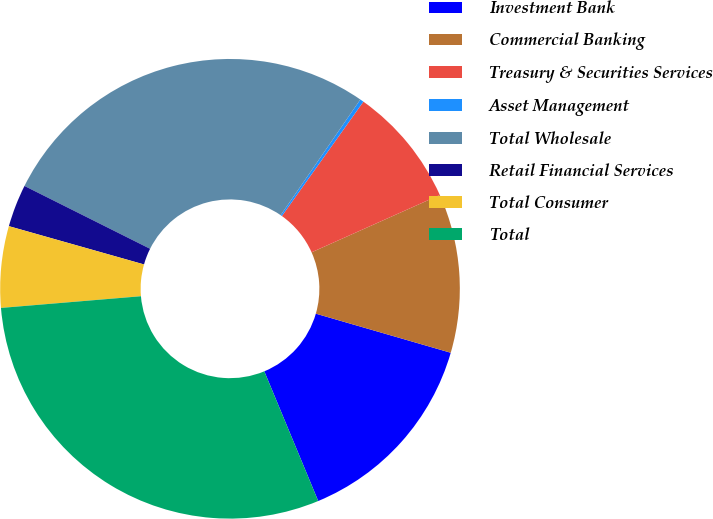<chart> <loc_0><loc_0><loc_500><loc_500><pie_chart><fcel>Investment Bank<fcel>Commercial Banking<fcel>Treasury & Securities Services<fcel>Asset Management<fcel>Total Wholesale<fcel>Retail Financial Services<fcel>Total Consumer<fcel>Total<nl><fcel>14.24%<fcel>11.18%<fcel>8.45%<fcel>0.26%<fcel>27.21%<fcel>2.99%<fcel>5.72%<fcel>29.94%<nl></chart> 